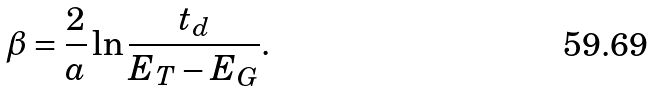Convert formula to latex. <formula><loc_0><loc_0><loc_500><loc_500>\beta = \frac { 2 } { a } \ln \frac { t _ { d } } { E _ { T } - E _ { G } } .</formula> 